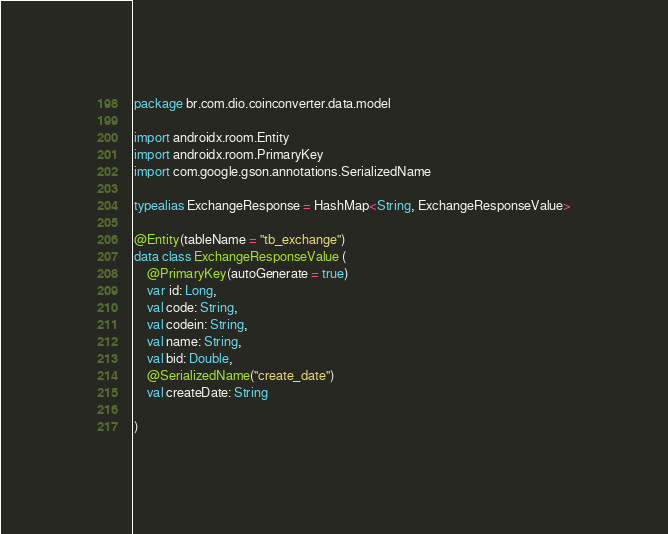<code> <loc_0><loc_0><loc_500><loc_500><_Kotlin_>package br.com.dio.coinconverter.data.model

import androidx.room.Entity
import androidx.room.PrimaryKey
import com.google.gson.annotations.SerializedName

typealias ExchangeResponse = HashMap<String, ExchangeResponseValue>

@Entity(tableName = "tb_exchange")
data class ExchangeResponseValue (
    @PrimaryKey(autoGenerate = true)
    var id: Long,
    val code: String,
    val codein: String,
    val name: String,
    val bid: Double,
    @SerializedName("create_date")
    val createDate: String

)
</code> 